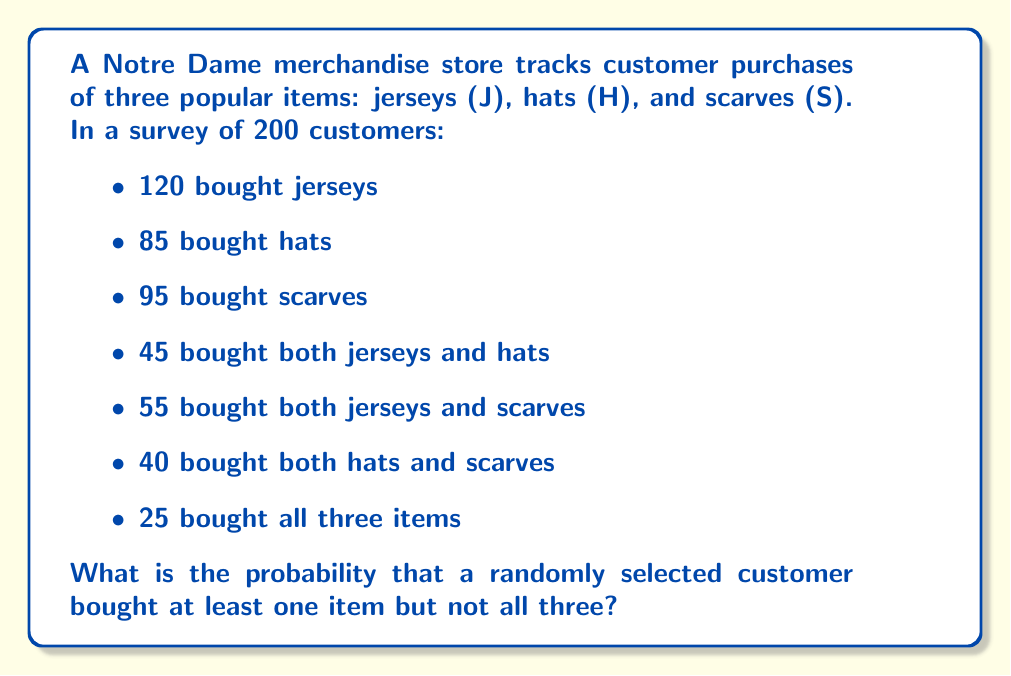Teach me how to tackle this problem. Let's approach this step-by-step using set theory and probability:

1) First, we need to find the number of customers who bought at least one item. We can use the inclusion-exclusion principle:

   $$|J \cup H \cup S| = |J| + |H| + |S| - |J \cap H| - |J \cap S| - |H \cap S| + |J \cap H \cap S|$$

   $$ = 120 + 85 + 95 - 45 - 55 - 40 + 25 = 185 $$

2) Now, we know that 25 customers bought all three items.

3) Therefore, the number of customers who bought at least one item but not all three is:

   $$ 185 - 25 = 160 $$

4) To calculate the probability, we divide this number by the total number of customers:

   $$ P(\text{at least one but not all}) = \frac{160}{200} = \frac{4}{5} = 0.8 $$
Answer: The probability that a randomly selected customer bought at least one item but not all three is $\frac{4}{5}$ or 0.8 or 80%. 